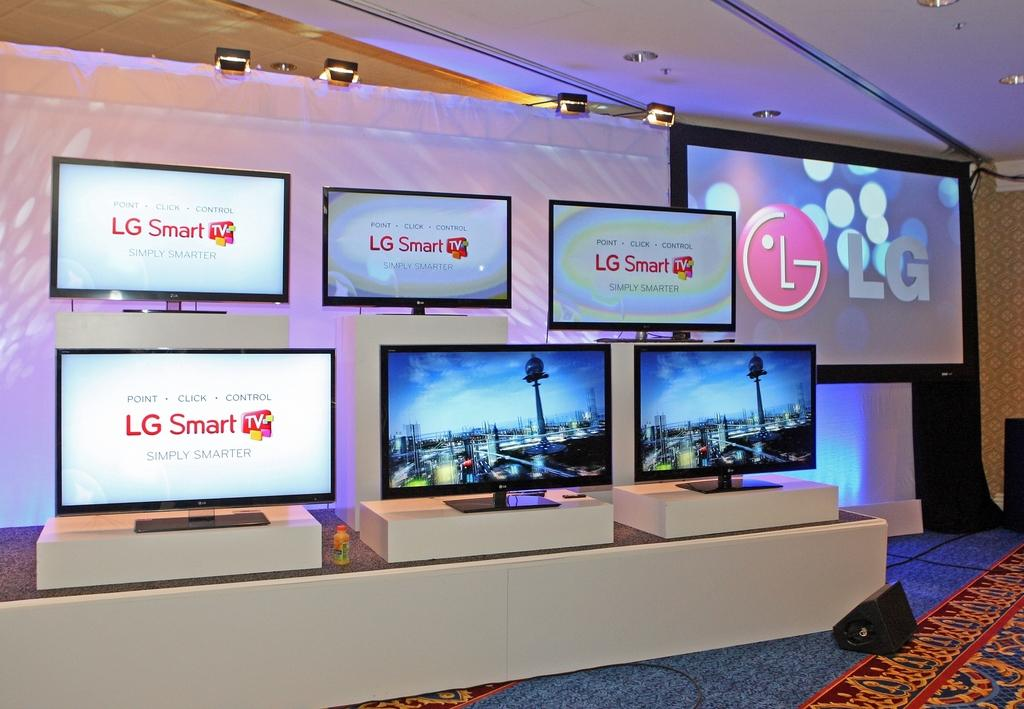<image>
Provide a brief description of the given image. Several LG Smart TV's on display on the walls and on a platform. 